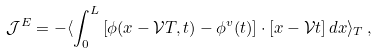Convert formula to latex. <formula><loc_0><loc_0><loc_500><loc_500>\mathcal { J } ^ { E } = - \langle \int _ { 0 } ^ { L } \left [ \phi ( x - \mathcal { V } T , t ) - \phi ^ { v } ( t ) \right ] \cdot \left [ x - \mathcal { V } t \right ] d x \rangle _ { T } \, ,</formula> 